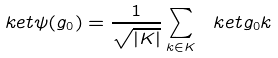Convert formula to latex. <formula><loc_0><loc_0><loc_500><loc_500>\ k e t { \psi ( g _ { 0 } ) } = \frac { 1 } { \sqrt { | K | } } \sum _ { k \in K } \ k e t { g _ { 0 } k }</formula> 